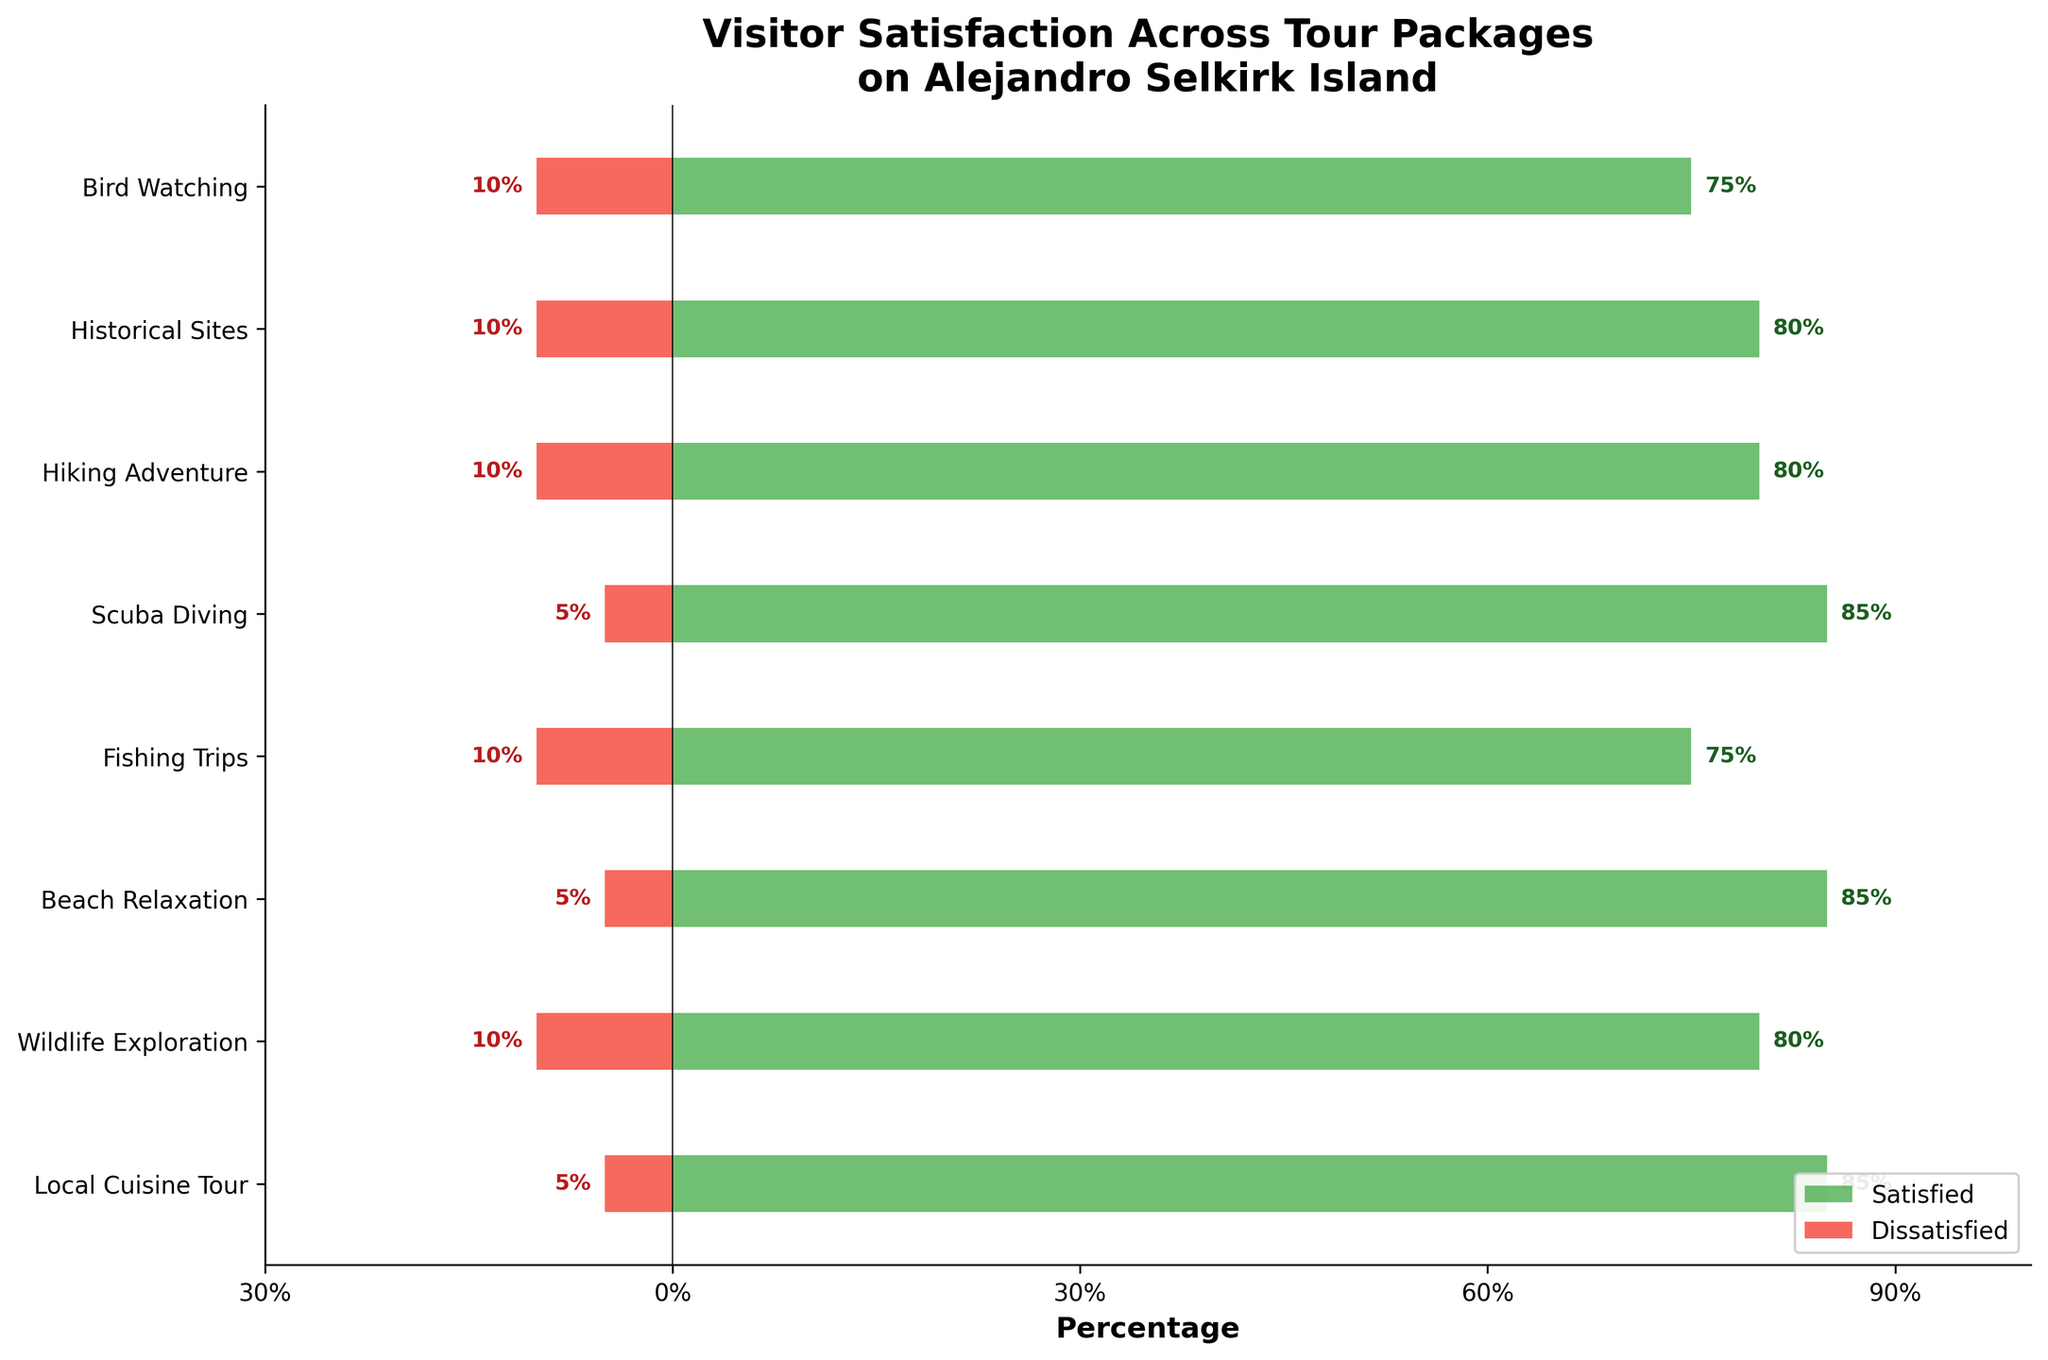Which tour package has the highest percentage of highly satisfied visitors? The "Beach Relaxation" tour package has the highest light green bar, indicating the highest percentage of highly satisfied visitors at 60%.
Answer: Beach Relaxation Which tour package has the smallest combined percentage of dissatisfied and highly dissatisfied visitors? To find the tour package with the smallest red bar, identify the lowest combined percentage of dissatisfied (red color) and highly dissatisfied (dark red color) visitors, which is the "Scuba Diving" package at 5%.
Answer: Scuba Diving How does the satisfaction level of the "Historical Sites" tour compare to the "Local Cuisine Tour"? Compare the lengths of the green (satisfied) and red (dissatisfied) bars. "Historic Sites" has a 80% satisfaction rate (50% highly satisfied and 30% satisfied) and a 10% dissatisfaction rate, whereas "Local Cuisine Tour" has an 85% satisfaction rate (55% highly satisfied and 30% satisfied) and a 5% dissatisfaction rate.
Answer: Local Cuisine Tour has a higher satisfaction rate What is the combined percentage of neutral visitors across all tour packages? Add the percentages of neutral visitors (gray color) for all tour packages: 15% (Bird Watching) + 10% (Historical Sites) + 10% (Hiking Adventure) + 10% (Scuba Diving) + 15% (Fishing Trips) + 10% (Beach Relaxation) + 10% (Wildlife Exploration) + 10% (Local Cuisine Tour). The sum is 90%.
Answer: 90% Which tour package shows an equal percentage of highly satisfied and neutral visitors? Check for a tour package where the light green bar for highly satisfied and the gray bar for neutral have the same length. The "Hiking Adventure" tour package has equal percentages for highly satisfied and neutral visitors at 10%.
Answer: Hiking Adventure Which tour package shows the highest dissatisfaction level and by how much percentage? Identify the longest red bar for dissatisfaction (combine dissatisfied and highly dissatisfied percentages). The "Historical Sites" and "Wildlife Exploration" both have the highest dissatisfaction level at 15% each.
Answer: Historical Sites and Wildlife Exploration, 15% 